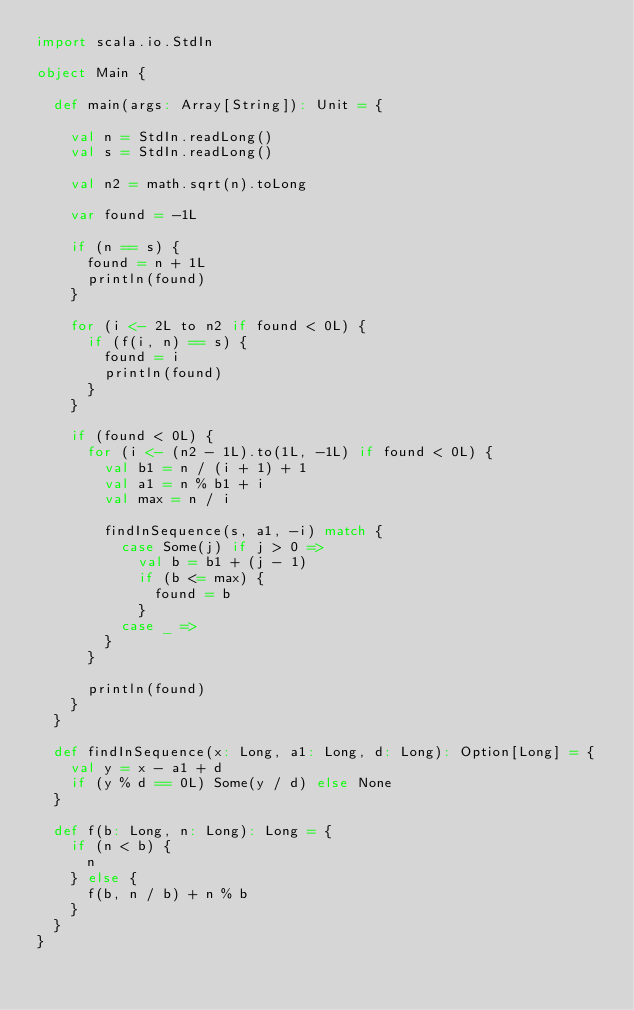<code> <loc_0><loc_0><loc_500><loc_500><_Scala_>import scala.io.StdIn

object Main {

  def main(args: Array[String]): Unit = {

    val n = StdIn.readLong()
    val s = StdIn.readLong()

    val n2 = math.sqrt(n).toLong

    var found = -1L

    if (n == s) {
      found = n + 1L
      println(found)
    }

    for (i <- 2L to n2 if found < 0L) {
      if (f(i, n) == s) {
        found = i
        println(found)
      }
    }

    if (found < 0L) {
      for (i <- (n2 - 1L).to(1L, -1L) if found < 0L) {
        val b1 = n / (i + 1) + 1
        val a1 = n % b1 + i
        val max = n / i

        findInSequence(s, a1, -i) match {
          case Some(j) if j > 0 =>
            val b = b1 + (j - 1)
            if (b <= max) {
              found = b
            }
          case _ =>
        }
      }

      println(found)
    }
  }

  def findInSequence(x: Long, a1: Long, d: Long): Option[Long] = {
    val y = x - a1 + d
    if (y % d == 0L) Some(y / d) else None
  }

  def f(b: Long, n: Long): Long = {
    if (n < b) {
      n
    } else {
      f(b, n / b) + n % b
    }
  }
}

</code> 